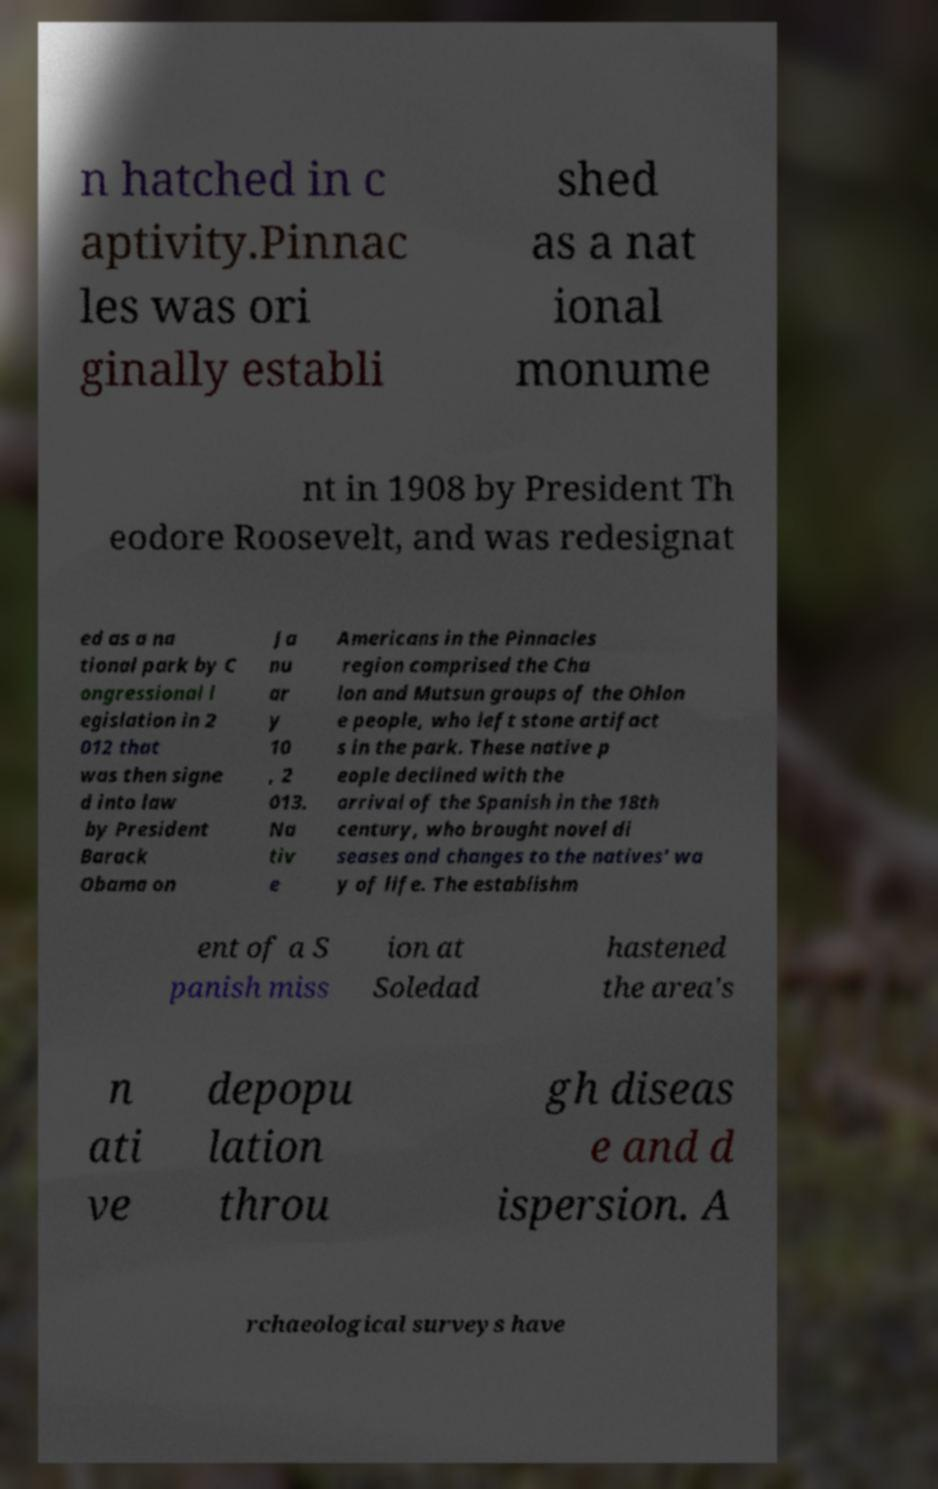Could you assist in decoding the text presented in this image and type it out clearly? n hatched in c aptivity.Pinnac les was ori ginally establi shed as a nat ional monume nt in 1908 by President Th eodore Roosevelt, and was redesignat ed as a na tional park by C ongressional l egislation in 2 012 that was then signe d into law by President Barack Obama on Ja nu ar y 10 , 2 013. Na tiv e Americans in the Pinnacles region comprised the Cha lon and Mutsun groups of the Ohlon e people, who left stone artifact s in the park. These native p eople declined with the arrival of the Spanish in the 18th century, who brought novel di seases and changes to the natives' wa y of life. The establishm ent of a S panish miss ion at Soledad hastened the area's n ati ve depopu lation throu gh diseas e and d ispersion. A rchaeological surveys have 